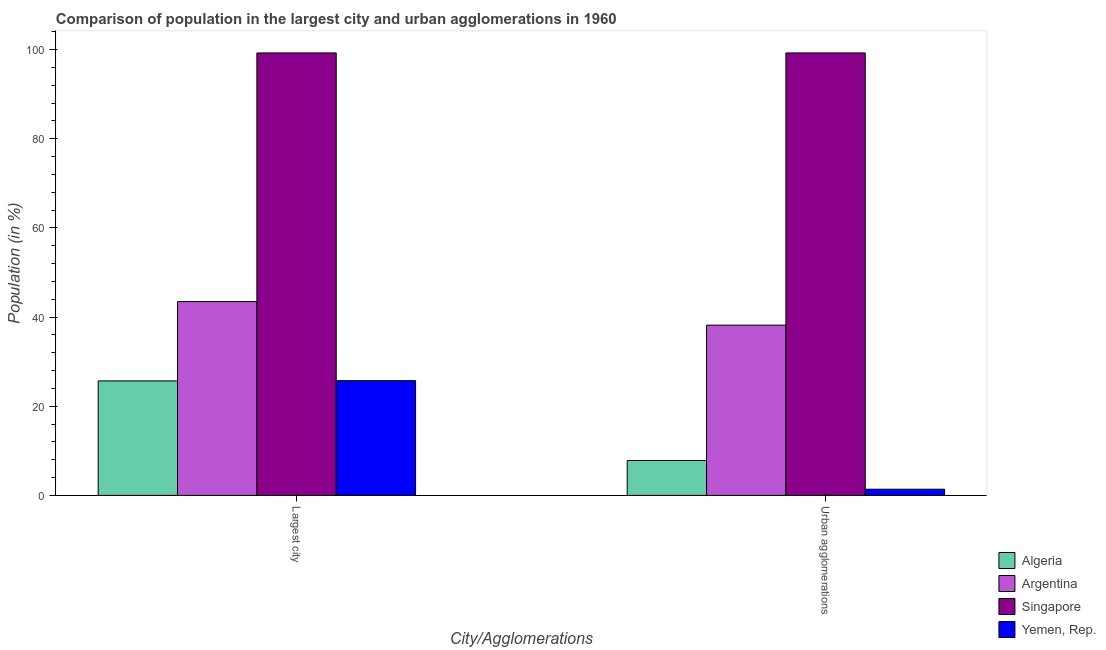How many groups of bars are there?
Offer a terse response. 2. How many bars are there on the 2nd tick from the right?
Provide a succinct answer. 4. What is the label of the 2nd group of bars from the left?
Ensure brevity in your answer.  Urban agglomerations. What is the population in urban agglomerations in Argentina?
Offer a terse response. 38.19. Across all countries, what is the maximum population in urban agglomerations?
Provide a succinct answer. 99.23. Across all countries, what is the minimum population in urban agglomerations?
Give a very brief answer. 1.39. In which country was the population in urban agglomerations maximum?
Your response must be concise. Singapore. In which country was the population in the largest city minimum?
Keep it short and to the point. Algeria. What is the total population in the largest city in the graph?
Offer a very short reply. 194.12. What is the difference between the population in the largest city in Argentina and that in Yemen, Rep.?
Ensure brevity in your answer.  17.73. What is the difference between the population in the largest city in Algeria and the population in urban agglomerations in Argentina?
Give a very brief answer. -12.51. What is the average population in urban agglomerations per country?
Your response must be concise. 36.66. What is the difference between the population in urban agglomerations and population in the largest city in Singapore?
Offer a very short reply. 0. In how many countries, is the population in the largest city greater than 24 %?
Keep it short and to the point. 4. What is the ratio of the population in urban agglomerations in Yemen, Rep. to that in Singapore?
Your answer should be compact. 0.01. In how many countries, is the population in the largest city greater than the average population in the largest city taken over all countries?
Make the answer very short. 1. What does the 1st bar from the left in Urban agglomerations represents?
Ensure brevity in your answer.  Algeria. Are all the bars in the graph horizontal?
Keep it short and to the point. No. How many countries are there in the graph?
Your response must be concise. 4. Are the values on the major ticks of Y-axis written in scientific E-notation?
Provide a short and direct response. No. Does the graph contain any zero values?
Your answer should be compact. No. How many legend labels are there?
Your response must be concise. 4. What is the title of the graph?
Offer a very short reply. Comparison of population in the largest city and urban agglomerations in 1960. Does "South Sudan" appear as one of the legend labels in the graph?
Keep it short and to the point. No. What is the label or title of the X-axis?
Give a very brief answer. City/Agglomerations. What is the label or title of the Y-axis?
Your answer should be compact. Population (in %). What is the Population (in %) of Algeria in Largest city?
Your answer should be very brief. 25.68. What is the Population (in %) in Argentina in Largest city?
Provide a succinct answer. 43.47. What is the Population (in %) in Singapore in Largest city?
Provide a succinct answer. 99.23. What is the Population (in %) in Yemen, Rep. in Largest city?
Offer a very short reply. 25.74. What is the Population (in %) of Algeria in Urban agglomerations?
Offer a very short reply. 7.84. What is the Population (in %) of Argentina in Urban agglomerations?
Offer a very short reply. 38.19. What is the Population (in %) of Singapore in Urban agglomerations?
Provide a succinct answer. 99.23. What is the Population (in %) of Yemen, Rep. in Urban agglomerations?
Ensure brevity in your answer.  1.39. Across all City/Agglomerations, what is the maximum Population (in %) of Algeria?
Offer a terse response. 25.68. Across all City/Agglomerations, what is the maximum Population (in %) of Argentina?
Your response must be concise. 43.47. Across all City/Agglomerations, what is the maximum Population (in %) of Singapore?
Offer a terse response. 99.23. Across all City/Agglomerations, what is the maximum Population (in %) of Yemen, Rep.?
Your answer should be very brief. 25.74. Across all City/Agglomerations, what is the minimum Population (in %) of Algeria?
Give a very brief answer. 7.84. Across all City/Agglomerations, what is the minimum Population (in %) in Argentina?
Make the answer very short. 38.19. Across all City/Agglomerations, what is the minimum Population (in %) in Singapore?
Provide a succinct answer. 99.23. Across all City/Agglomerations, what is the minimum Population (in %) in Yemen, Rep.?
Your answer should be very brief. 1.39. What is the total Population (in %) of Algeria in the graph?
Make the answer very short. 33.52. What is the total Population (in %) in Argentina in the graph?
Ensure brevity in your answer.  81.66. What is the total Population (in %) in Singapore in the graph?
Your answer should be compact. 198.46. What is the total Population (in %) in Yemen, Rep. in the graph?
Keep it short and to the point. 27.13. What is the difference between the Population (in %) in Algeria in Largest city and that in Urban agglomerations?
Your answer should be very brief. 17.85. What is the difference between the Population (in %) of Argentina in Largest city and that in Urban agglomerations?
Ensure brevity in your answer.  5.28. What is the difference between the Population (in %) in Yemen, Rep. in Largest city and that in Urban agglomerations?
Keep it short and to the point. 24.34. What is the difference between the Population (in %) of Algeria in Largest city and the Population (in %) of Argentina in Urban agglomerations?
Provide a succinct answer. -12.51. What is the difference between the Population (in %) of Algeria in Largest city and the Population (in %) of Singapore in Urban agglomerations?
Offer a terse response. -73.55. What is the difference between the Population (in %) in Algeria in Largest city and the Population (in %) in Yemen, Rep. in Urban agglomerations?
Offer a very short reply. 24.29. What is the difference between the Population (in %) in Argentina in Largest city and the Population (in %) in Singapore in Urban agglomerations?
Provide a succinct answer. -55.76. What is the difference between the Population (in %) of Argentina in Largest city and the Population (in %) of Yemen, Rep. in Urban agglomerations?
Provide a succinct answer. 42.08. What is the difference between the Population (in %) in Singapore in Largest city and the Population (in %) in Yemen, Rep. in Urban agglomerations?
Give a very brief answer. 97.84. What is the average Population (in %) in Algeria per City/Agglomerations?
Ensure brevity in your answer.  16.76. What is the average Population (in %) in Argentina per City/Agglomerations?
Ensure brevity in your answer.  40.83. What is the average Population (in %) in Singapore per City/Agglomerations?
Your response must be concise. 99.23. What is the average Population (in %) in Yemen, Rep. per City/Agglomerations?
Your response must be concise. 13.57. What is the difference between the Population (in %) in Algeria and Population (in %) in Argentina in Largest city?
Your answer should be very brief. -17.79. What is the difference between the Population (in %) of Algeria and Population (in %) of Singapore in Largest city?
Your response must be concise. -73.55. What is the difference between the Population (in %) in Algeria and Population (in %) in Yemen, Rep. in Largest city?
Provide a short and direct response. -0.06. What is the difference between the Population (in %) in Argentina and Population (in %) in Singapore in Largest city?
Your answer should be compact. -55.76. What is the difference between the Population (in %) of Argentina and Population (in %) of Yemen, Rep. in Largest city?
Offer a terse response. 17.73. What is the difference between the Population (in %) in Singapore and Population (in %) in Yemen, Rep. in Largest city?
Your response must be concise. 73.49. What is the difference between the Population (in %) in Algeria and Population (in %) in Argentina in Urban agglomerations?
Your answer should be compact. -30.35. What is the difference between the Population (in %) of Algeria and Population (in %) of Singapore in Urban agglomerations?
Provide a succinct answer. -91.39. What is the difference between the Population (in %) in Algeria and Population (in %) in Yemen, Rep. in Urban agglomerations?
Keep it short and to the point. 6.44. What is the difference between the Population (in %) in Argentina and Population (in %) in Singapore in Urban agglomerations?
Provide a succinct answer. -61.04. What is the difference between the Population (in %) of Argentina and Population (in %) of Yemen, Rep. in Urban agglomerations?
Offer a terse response. 36.8. What is the difference between the Population (in %) of Singapore and Population (in %) of Yemen, Rep. in Urban agglomerations?
Give a very brief answer. 97.84. What is the ratio of the Population (in %) in Algeria in Largest city to that in Urban agglomerations?
Your answer should be compact. 3.28. What is the ratio of the Population (in %) in Argentina in Largest city to that in Urban agglomerations?
Give a very brief answer. 1.14. What is the ratio of the Population (in %) of Singapore in Largest city to that in Urban agglomerations?
Your response must be concise. 1. What is the ratio of the Population (in %) of Yemen, Rep. in Largest city to that in Urban agglomerations?
Make the answer very short. 18.47. What is the difference between the highest and the second highest Population (in %) of Algeria?
Your response must be concise. 17.85. What is the difference between the highest and the second highest Population (in %) in Argentina?
Your answer should be compact. 5.28. What is the difference between the highest and the second highest Population (in %) of Singapore?
Make the answer very short. 0. What is the difference between the highest and the second highest Population (in %) of Yemen, Rep.?
Provide a short and direct response. 24.34. What is the difference between the highest and the lowest Population (in %) in Algeria?
Make the answer very short. 17.85. What is the difference between the highest and the lowest Population (in %) in Argentina?
Ensure brevity in your answer.  5.28. What is the difference between the highest and the lowest Population (in %) of Yemen, Rep.?
Ensure brevity in your answer.  24.34. 